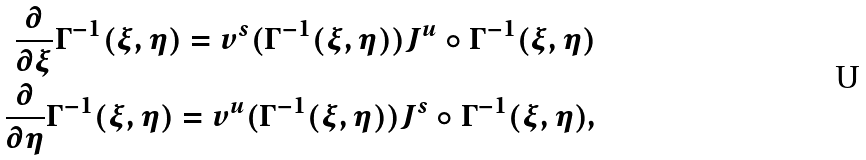<formula> <loc_0><loc_0><loc_500><loc_500>\frac { \partial } { \partial \xi } \Gamma ^ { - 1 } ( \xi , \eta ) = v ^ { s } ( \Gamma ^ { - 1 } ( \xi , \eta ) ) J ^ { u } \circ \Gamma ^ { - 1 } ( \xi , \eta ) \\ \frac { \partial } { \partial \eta } \Gamma ^ { - 1 } ( \xi , \eta ) = v ^ { u } ( \Gamma ^ { - 1 } ( \xi , \eta ) ) J ^ { s } \circ \Gamma ^ { - 1 } ( \xi , \eta ) ,</formula> 